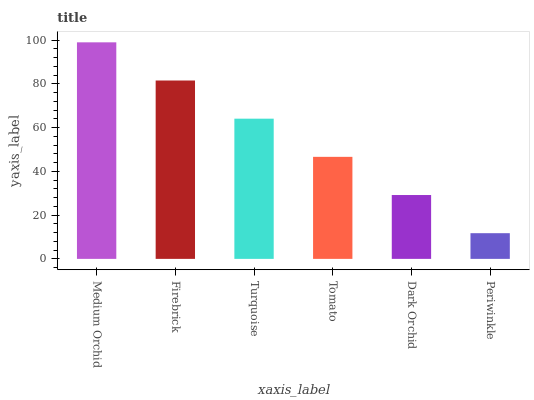Is Firebrick the minimum?
Answer yes or no. No. Is Firebrick the maximum?
Answer yes or no. No. Is Medium Orchid greater than Firebrick?
Answer yes or no. Yes. Is Firebrick less than Medium Orchid?
Answer yes or no. Yes. Is Firebrick greater than Medium Orchid?
Answer yes or no. No. Is Medium Orchid less than Firebrick?
Answer yes or no. No. Is Turquoise the high median?
Answer yes or no. Yes. Is Tomato the low median?
Answer yes or no. Yes. Is Dark Orchid the high median?
Answer yes or no. No. Is Dark Orchid the low median?
Answer yes or no. No. 